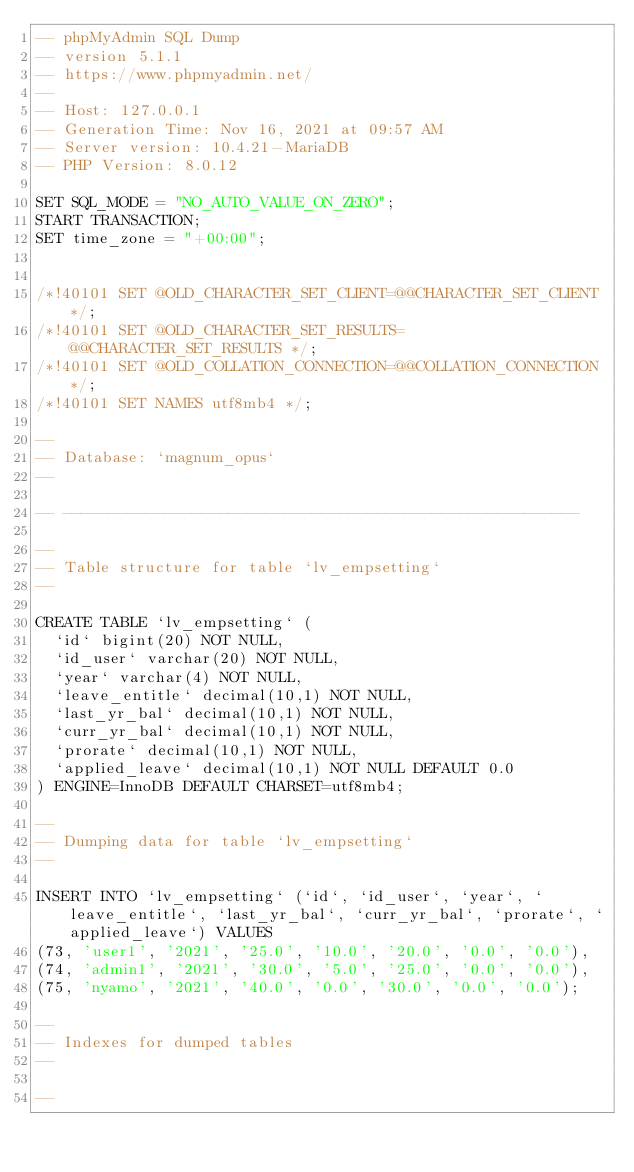<code> <loc_0><loc_0><loc_500><loc_500><_SQL_>-- phpMyAdmin SQL Dump
-- version 5.1.1
-- https://www.phpmyadmin.net/
--
-- Host: 127.0.0.1
-- Generation Time: Nov 16, 2021 at 09:57 AM
-- Server version: 10.4.21-MariaDB
-- PHP Version: 8.0.12

SET SQL_MODE = "NO_AUTO_VALUE_ON_ZERO";
START TRANSACTION;
SET time_zone = "+00:00";


/*!40101 SET @OLD_CHARACTER_SET_CLIENT=@@CHARACTER_SET_CLIENT */;
/*!40101 SET @OLD_CHARACTER_SET_RESULTS=@@CHARACTER_SET_RESULTS */;
/*!40101 SET @OLD_COLLATION_CONNECTION=@@COLLATION_CONNECTION */;
/*!40101 SET NAMES utf8mb4 */;

--
-- Database: `magnum_opus`
--

-- --------------------------------------------------------

--
-- Table structure for table `lv_empsetting`
--

CREATE TABLE `lv_empsetting` (
  `id` bigint(20) NOT NULL,
  `id_user` varchar(20) NOT NULL,
  `year` varchar(4) NOT NULL,
  `leave_entitle` decimal(10,1) NOT NULL,
  `last_yr_bal` decimal(10,1) NOT NULL,
  `curr_yr_bal` decimal(10,1) NOT NULL,
  `prorate` decimal(10,1) NOT NULL,
  `applied_leave` decimal(10,1) NOT NULL DEFAULT 0.0
) ENGINE=InnoDB DEFAULT CHARSET=utf8mb4;

--
-- Dumping data for table `lv_empsetting`
--

INSERT INTO `lv_empsetting` (`id`, `id_user`, `year`, `leave_entitle`, `last_yr_bal`, `curr_yr_bal`, `prorate`, `applied_leave`) VALUES
(73, 'user1', '2021', '25.0', '10.0', '20.0', '0.0', '0.0'),
(74, 'admin1', '2021', '30.0', '5.0', '25.0', '0.0', '0.0'),
(75, 'nyamo', '2021', '40.0', '0.0', '30.0', '0.0', '0.0');

--
-- Indexes for dumped tables
--

--</code> 